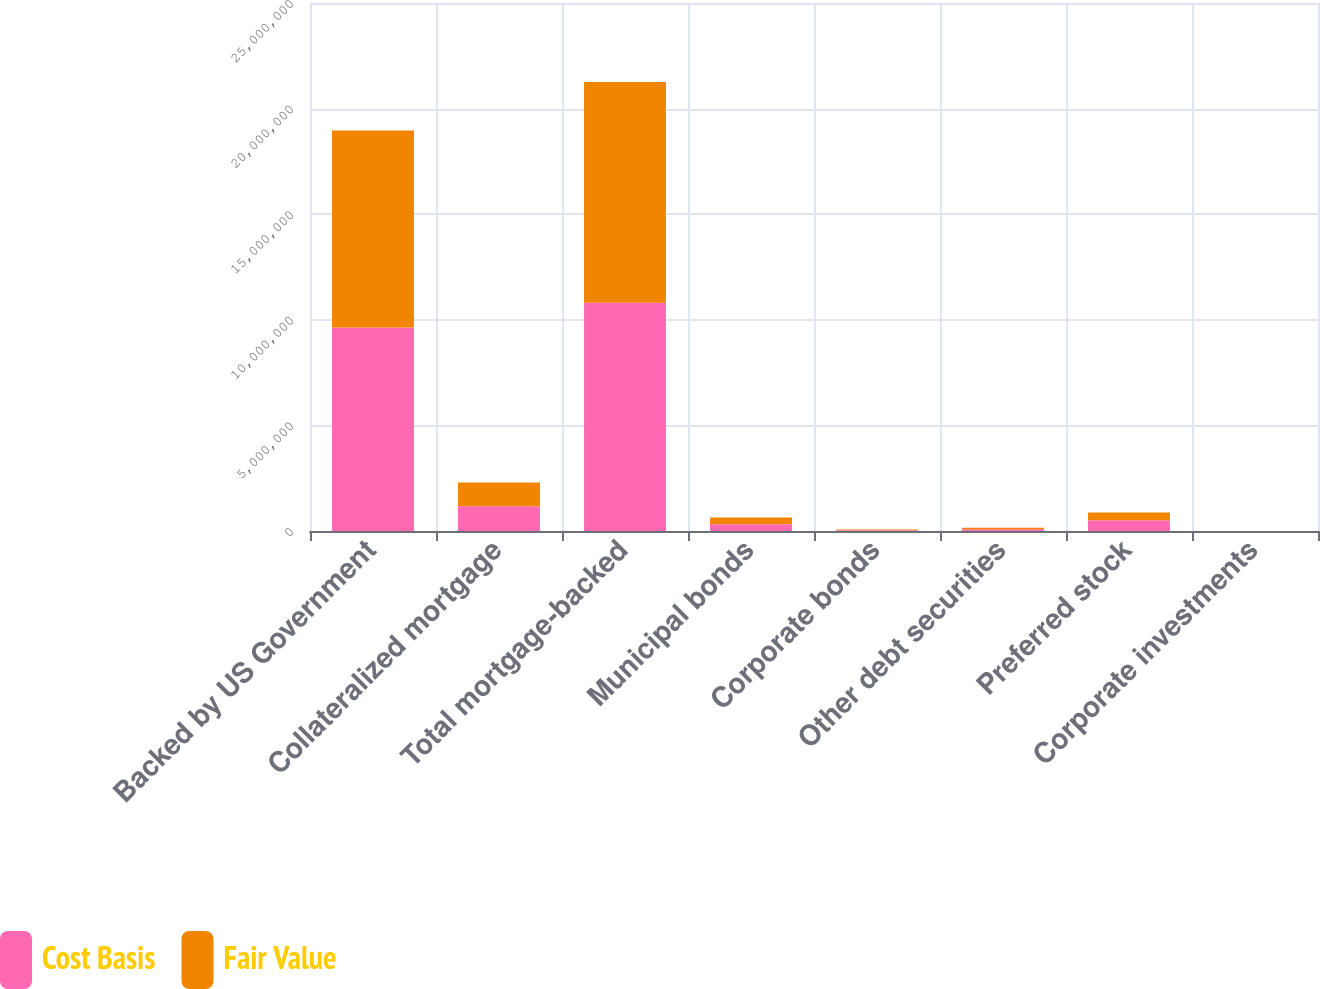<chart> <loc_0><loc_0><loc_500><loc_500><stacked_bar_chart><ecel><fcel>Backed by US Government<fcel>Collateralized mortgage<fcel>Total mortgage-backed<fcel>Municipal bonds<fcel>Corporate bonds<fcel>Other debt securities<fcel>Preferred stock<fcel>Corporate investments<nl><fcel>Cost Basis<fcel>9.63868e+06<fcel>1.17036e+06<fcel>1.0809e+07<fcel>320521<fcel>36557<fcel>78836<fcel>505498<fcel>1460<nl><fcel>Fair Value<fcel>9.33013e+06<fcel>1.12326e+06<fcel>1.04534e+07<fcel>314348<fcel>35279<fcel>77291<fcel>371404<fcel>1271<nl></chart> 